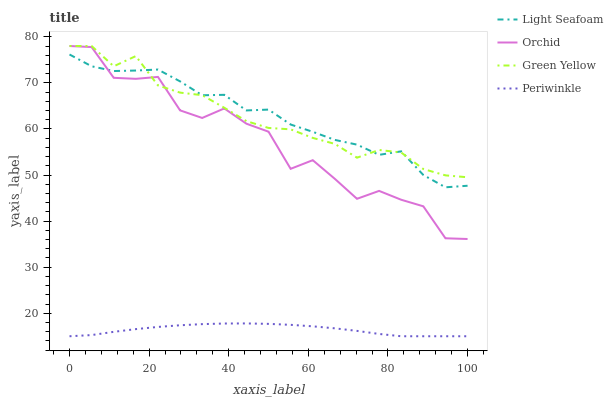Does Periwinkle have the minimum area under the curve?
Answer yes or no. Yes. Does Light Seafoam have the maximum area under the curve?
Answer yes or no. Yes. Does Light Seafoam have the minimum area under the curve?
Answer yes or no. No. Does Periwinkle have the maximum area under the curve?
Answer yes or no. No. Is Periwinkle the smoothest?
Answer yes or no. Yes. Is Orchid the roughest?
Answer yes or no. Yes. Is Light Seafoam the smoothest?
Answer yes or no. No. Is Light Seafoam the roughest?
Answer yes or no. No. Does Light Seafoam have the lowest value?
Answer yes or no. No. Does Orchid have the highest value?
Answer yes or no. Yes. Does Light Seafoam have the highest value?
Answer yes or no. No. Is Periwinkle less than Light Seafoam?
Answer yes or no. Yes. Is Green Yellow greater than Periwinkle?
Answer yes or no. Yes. Does Periwinkle intersect Light Seafoam?
Answer yes or no. No. 